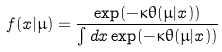<formula> <loc_0><loc_0><loc_500><loc_500>f ( x | \mu ) = \frac { \exp ( - \kappa \theta ( \mu | x ) ) } { \int d x \exp ( - \kappa \theta ( \mu | x ) ) }</formula> 